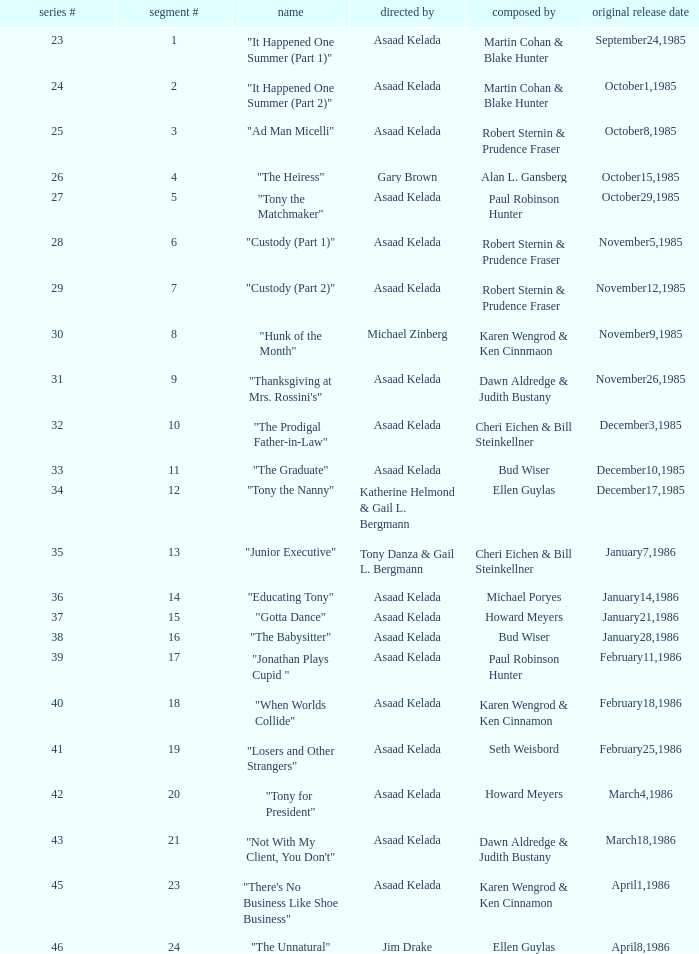What season features writer Michael Poryes? 14.0. 